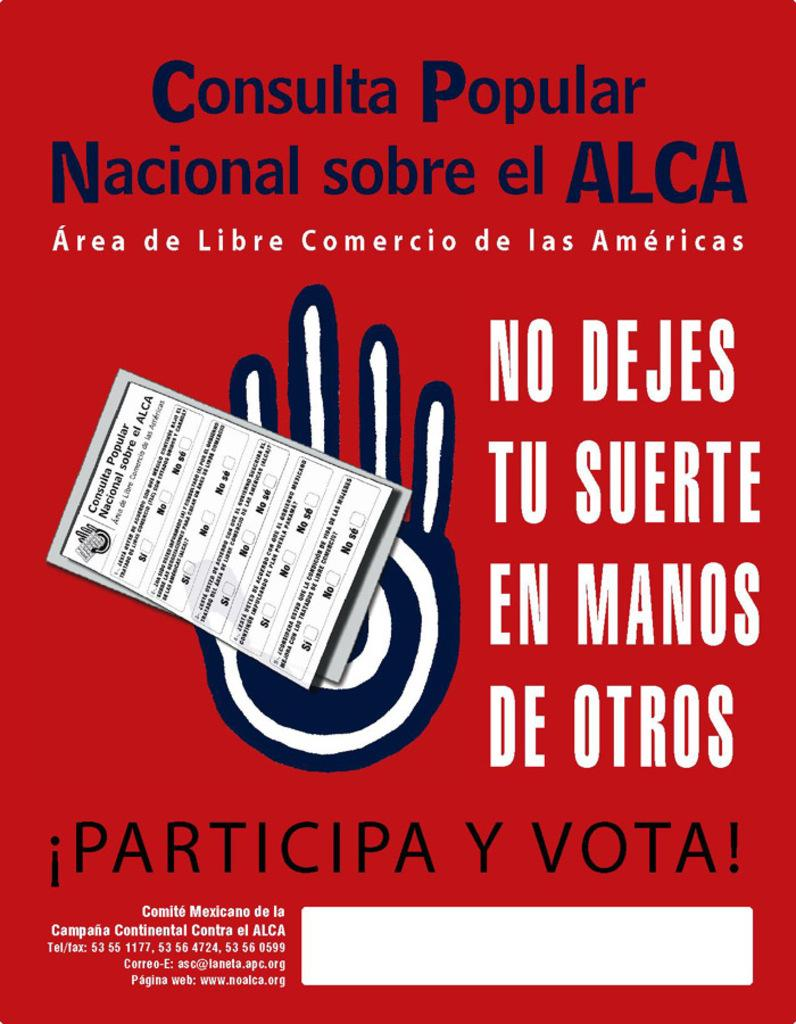Provide a one-sentence caption for the provided image. a red poster with a blue and white hand  reading !Particip Y Vota!. 